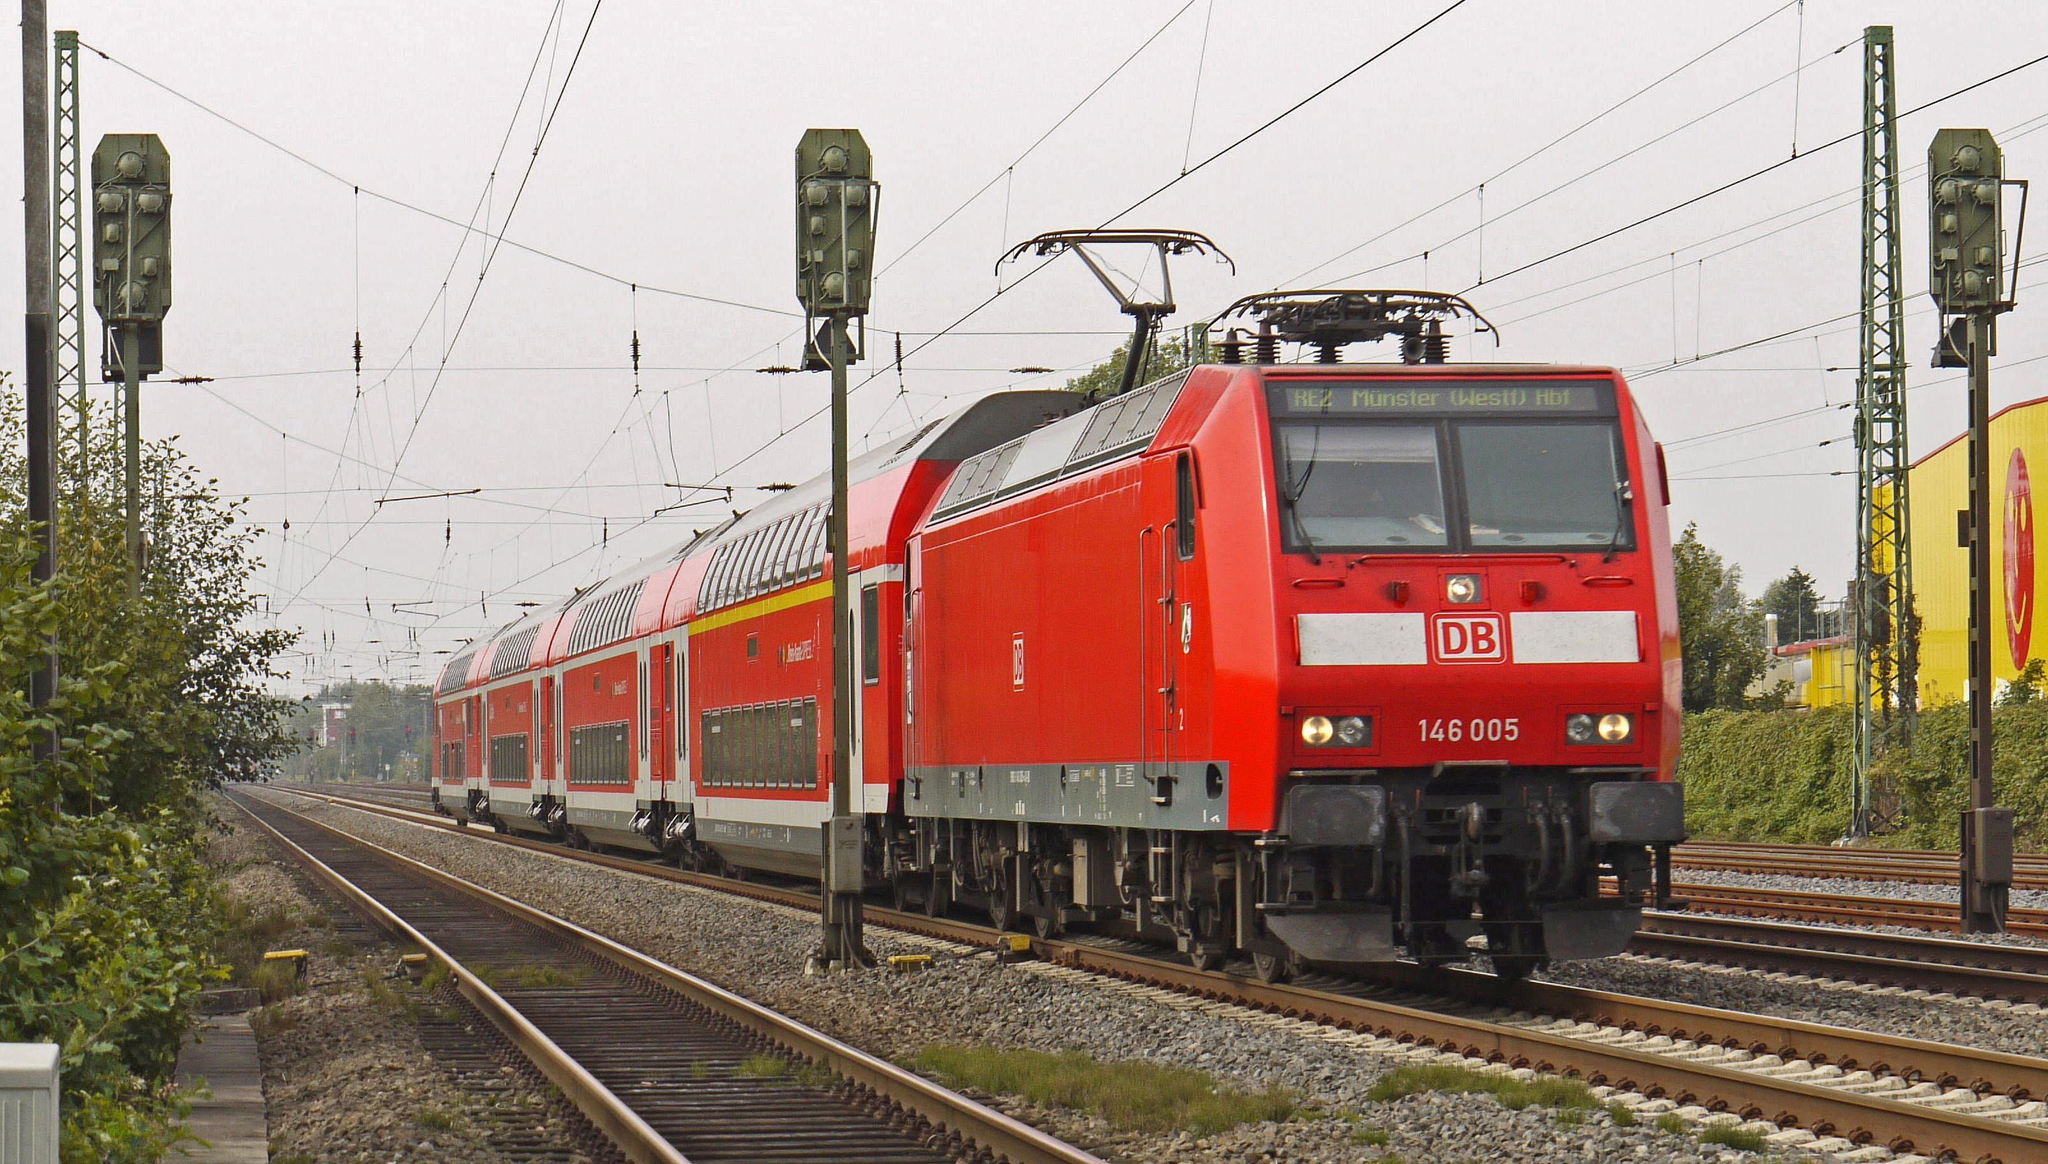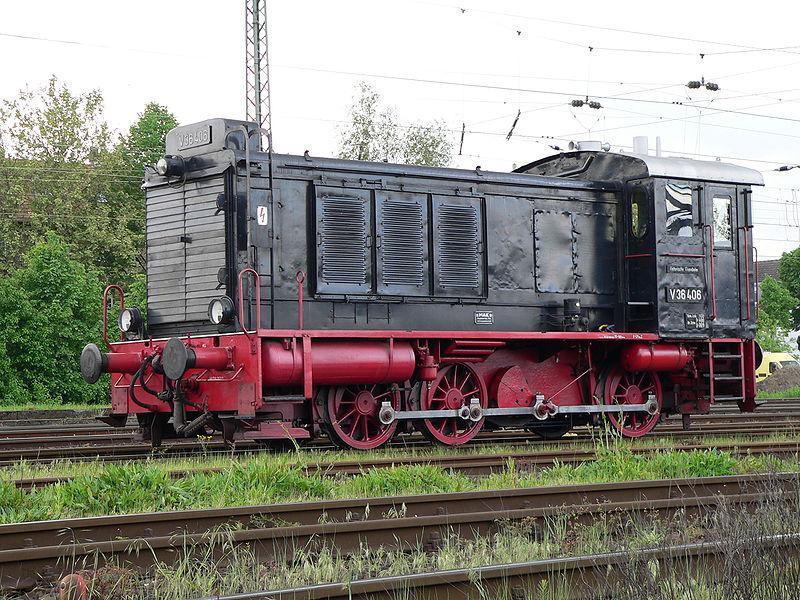The first image is the image on the left, the second image is the image on the right. Assess this claim about the two images: "The train in one of the images is black with red rims.". Correct or not? Answer yes or no. Yes. The first image is the image on the left, the second image is the image on the right. Given the left and right images, does the statement "Each image includes one predominantly red train on a track." hold true? Answer yes or no. No. 